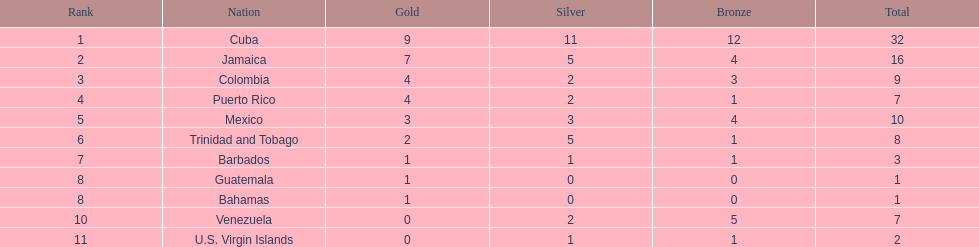What is the count of teams with over 9 medals? 3. 